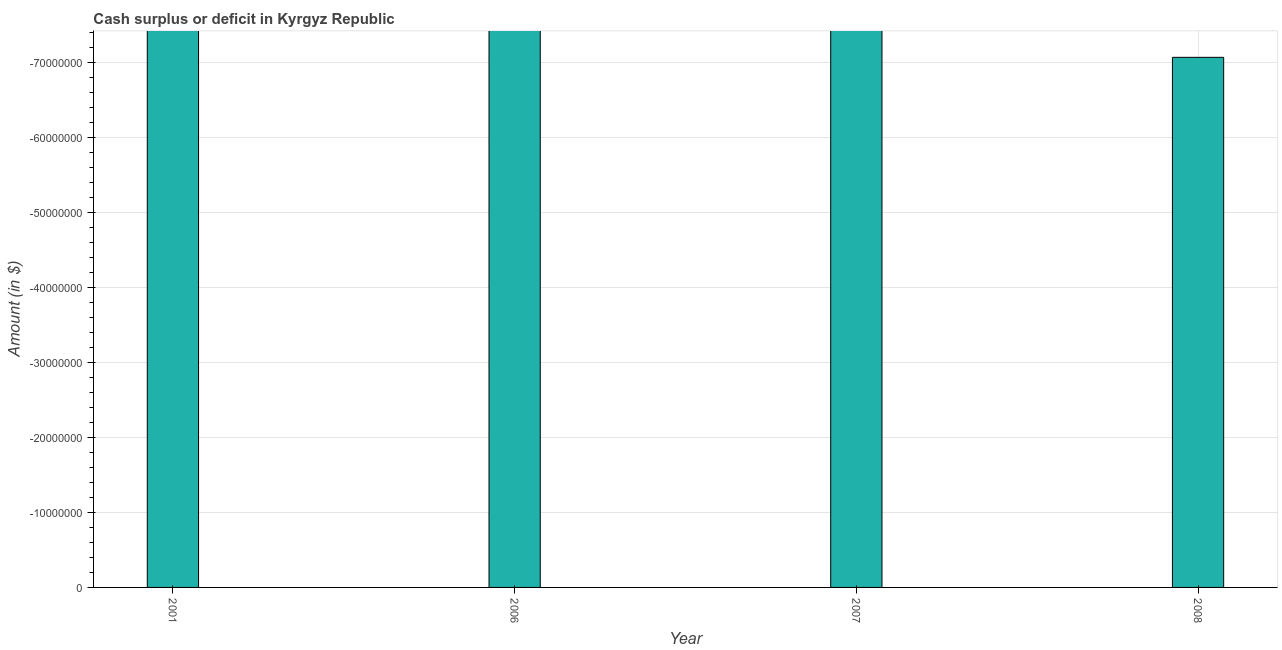Does the graph contain any zero values?
Offer a terse response. Yes. Does the graph contain grids?
Provide a succinct answer. Yes. What is the title of the graph?
Offer a very short reply. Cash surplus or deficit in Kyrgyz Republic. What is the label or title of the Y-axis?
Give a very brief answer. Amount (in $). What is the cash surplus or deficit in 2008?
Keep it short and to the point. 0. What is the average cash surplus or deficit per year?
Your answer should be very brief. 0. In how many years, is the cash surplus or deficit greater than -24000000 $?
Offer a very short reply. 0. How many bars are there?
Your answer should be compact. 0. Are all the bars in the graph horizontal?
Your response must be concise. No. Are the values on the major ticks of Y-axis written in scientific E-notation?
Your response must be concise. No. What is the Amount (in $) in 2006?
Your answer should be very brief. 0. What is the Amount (in $) of 2007?
Offer a very short reply. 0. What is the Amount (in $) in 2008?
Offer a very short reply. 0. 